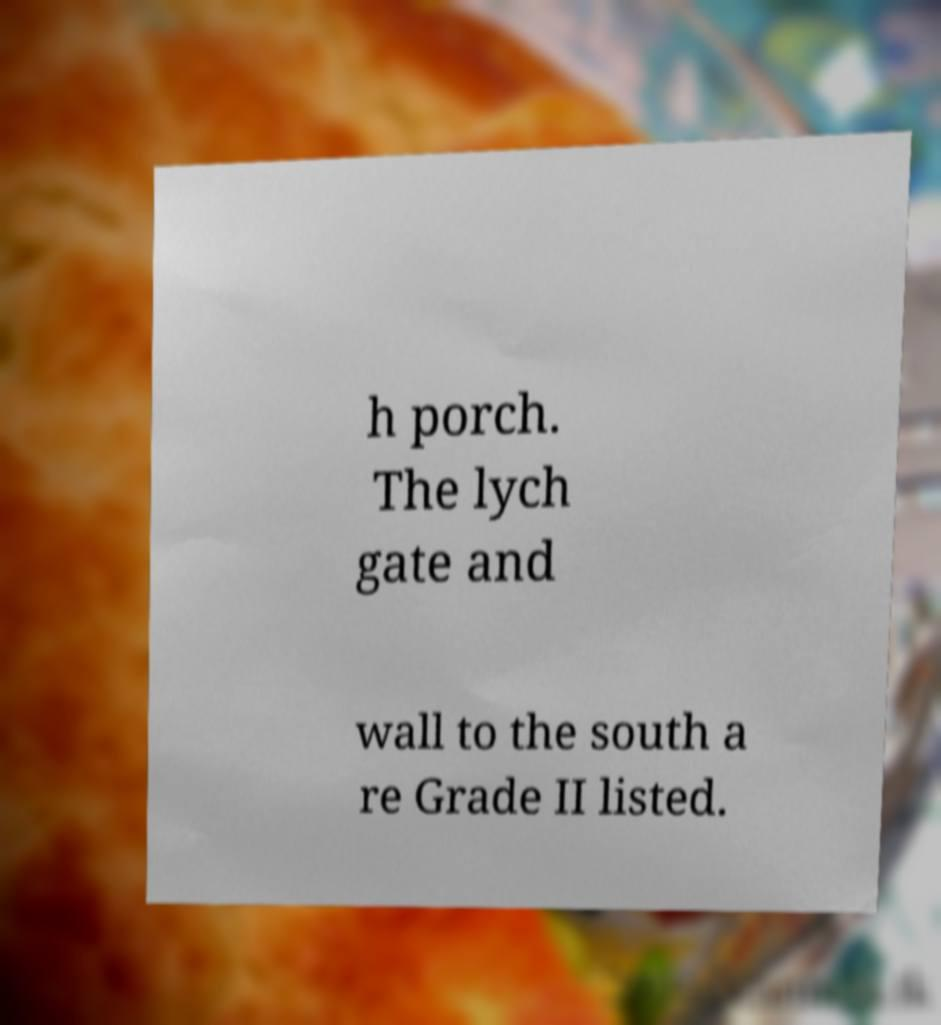Could you assist in decoding the text presented in this image and type it out clearly? h porch. The lych gate and wall to the south a re Grade II listed. 